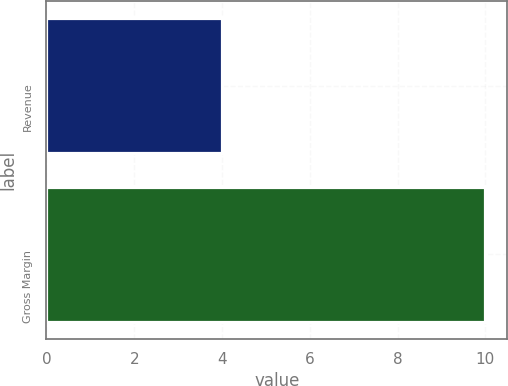Convert chart to OTSL. <chart><loc_0><loc_0><loc_500><loc_500><bar_chart><fcel>Revenue<fcel>Gross Margin<nl><fcel>4<fcel>10<nl></chart> 